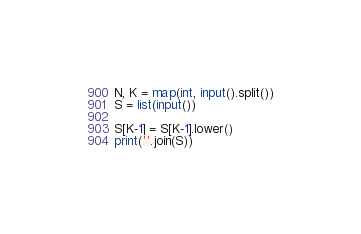<code> <loc_0><loc_0><loc_500><loc_500><_Python_>N, K = map(int, input().split())
S = list(input())

S[K-1] = S[K-1].lower()
print(''.join(S))</code> 